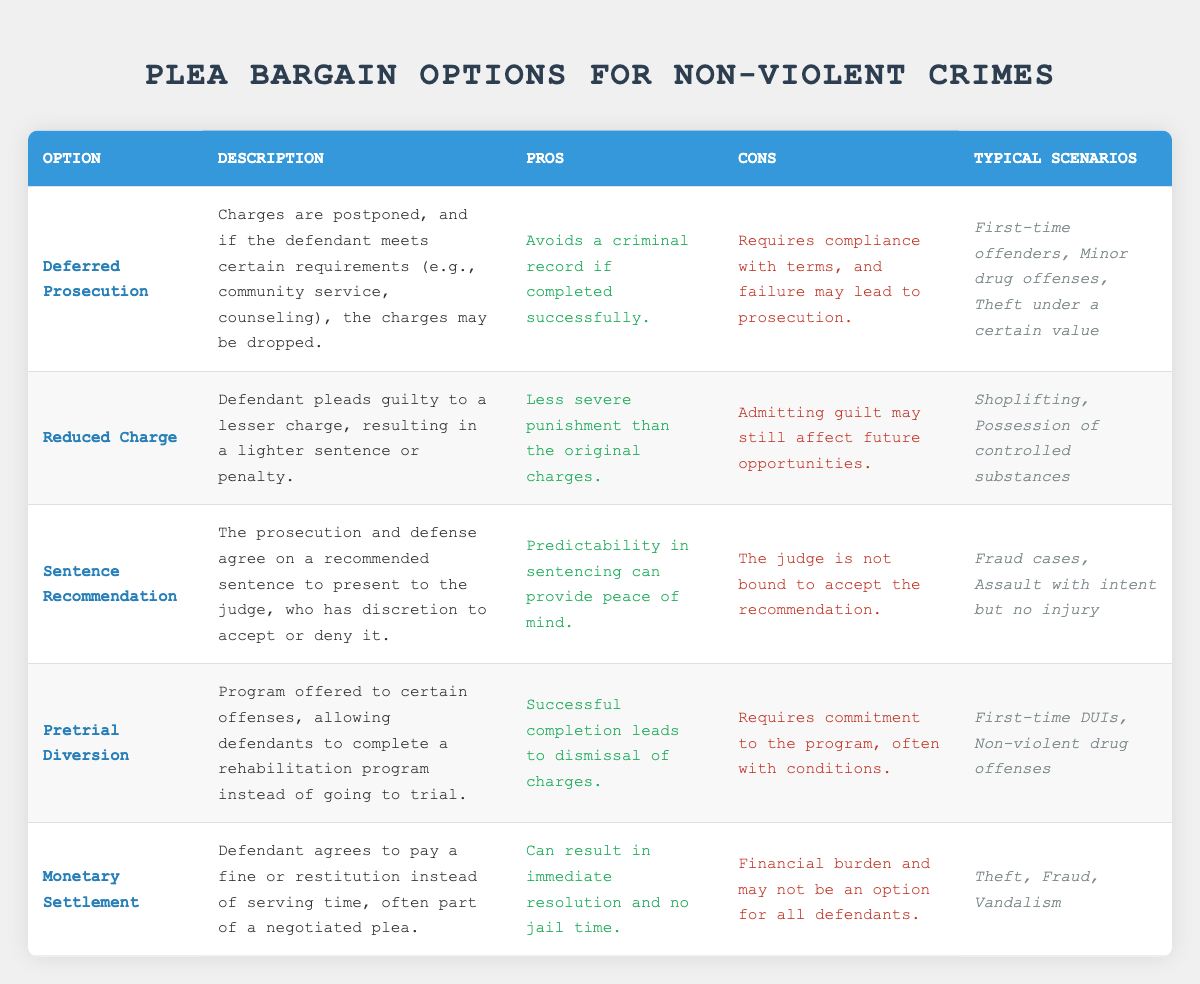What is the option that allows charges to be dropped if certain requirements are met? The table lists "Deferred Prosecution" as an option where charges are postponed and can be dropped if the defendant fulfills specific requirements.
Answer: Deferred Prosecution Which plea bargain option is designed for first-time offenders? The "Deferred Prosecution" and "Pretrial Diversion" options are both described as being suitable for first-time offenders in the typical scenarios section.
Answer: Deferred Prosecution, Pretrial Diversion What are the pros of the "Reduced Charge" option? The table states that the pros of the "Reduced Charge" are that it results in a less severe punishment than the original charges.
Answer: Less severe punishment What is a common scenario for using the "Monetary Settlement"? According to the table, the "Monetary Settlement" is often applied to cases involving theft, fraud, and vandalism.
Answer: Theft, fraud, vandalism Which plea bargain option has a con related to the necessity of completing a program? "Pretrial Diversion" is noted to have a requirement for commitment to a program, which is a key con listed in the table.
Answer: Pretrial Diversion Are there any options that result in avoiding a criminal record? Yes, "Deferred Prosecution" allows for avoiding a criminal record if the terms are successfully completed.
Answer: Yes What are the typical scenarios for "Sentence Recommendation"? The typical scenarios for "Sentence Recommendation" include fraud cases and assault with intent but no injury, as per the table.
Answer: Fraud cases, Assault with intent but no injury If a defendant pleads guilty to a lesser charge, what option is being used? This scenario refers to the "Reduced Charge" plea bargain option, where the defendant pleads guilty to a lesser charge.
Answer: Reduced Charge Is the judge required to accept the plea agreement in the "Sentence Recommendation"? No, the table indicates that the judge has discretion and is not required to accept the plea recommendation.
Answer: No In terms of immediate resolution and no jail time, which plea option is most beneficial? "Monetary Settlement" is highlighted in the pros as it can lead to immediate resolution without jail time.
Answer: Monetary Settlement How do the pros of "Pretrial Diversion" compare to its cons? The pros indicate successful completion leads to dismissal of charges, while the cons highlight the necessity of committing to a program with conditions, indicating that it requires effort but has a potential for positive outcome.
Answer: Requires commitment, leads to dismissal if successful 